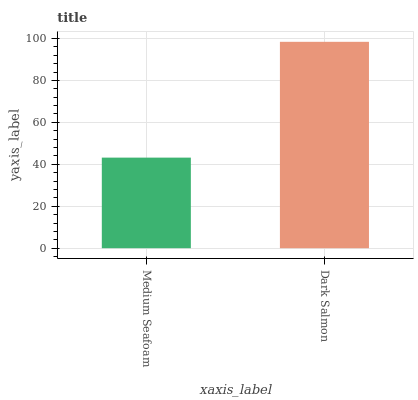Is Medium Seafoam the minimum?
Answer yes or no. Yes. Is Dark Salmon the maximum?
Answer yes or no. Yes. Is Dark Salmon the minimum?
Answer yes or no. No. Is Dark Salmon greater than Medium Seafoam?
Answer yes or no. Yes. Is Medium Seafoam less than Dark Salmon?
Answer yes or no. Yes. Is Medium Seafoam greater than Dark Salmon?
Answer yes or no. No. Is Dark Salmon less than Medium Seafoam?
Answer yes or no. No. Is Dark Salmon the high median?
Answer yes or no. Yes. Is Medium Seafoam the low median?
Answer yes or no. Yes. Is Medium Seafoam the high median?
Answer yes or no. No. Is Dark Salmon the low median?
Answer yes or no. No. 